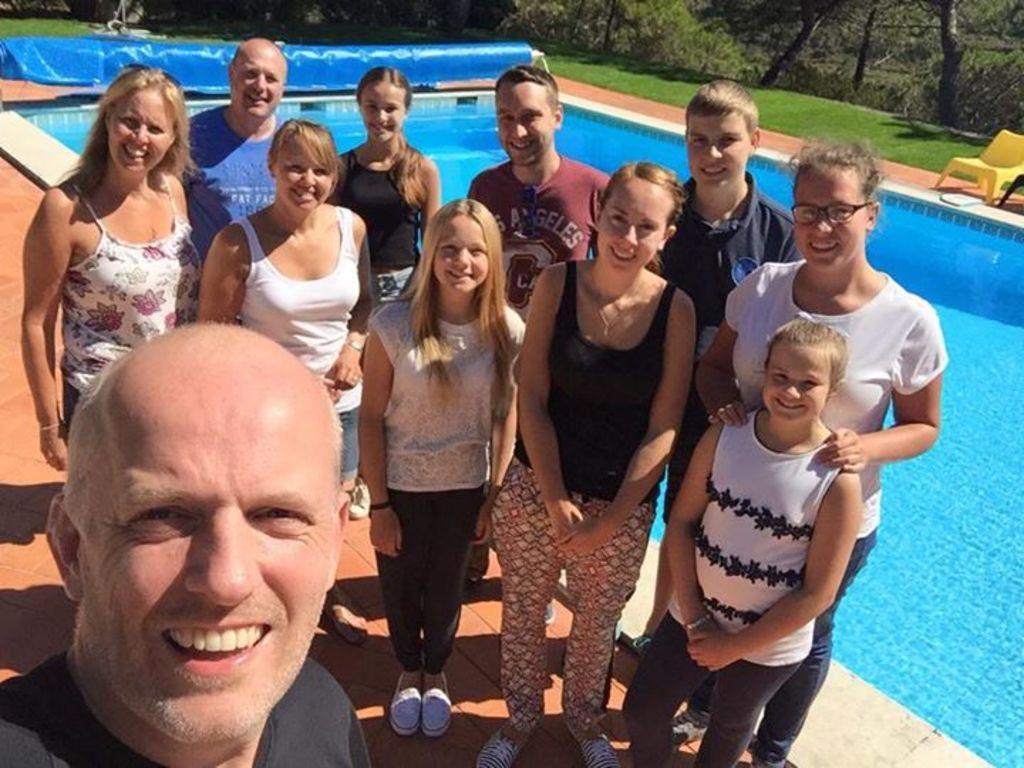Describe this image in one or two sentences. In this picture there are group of people standing and smiling. At the back there is water in the swimming pool and there are trees and there are chairs. At the bottom there is grass. At the back there is an object. 